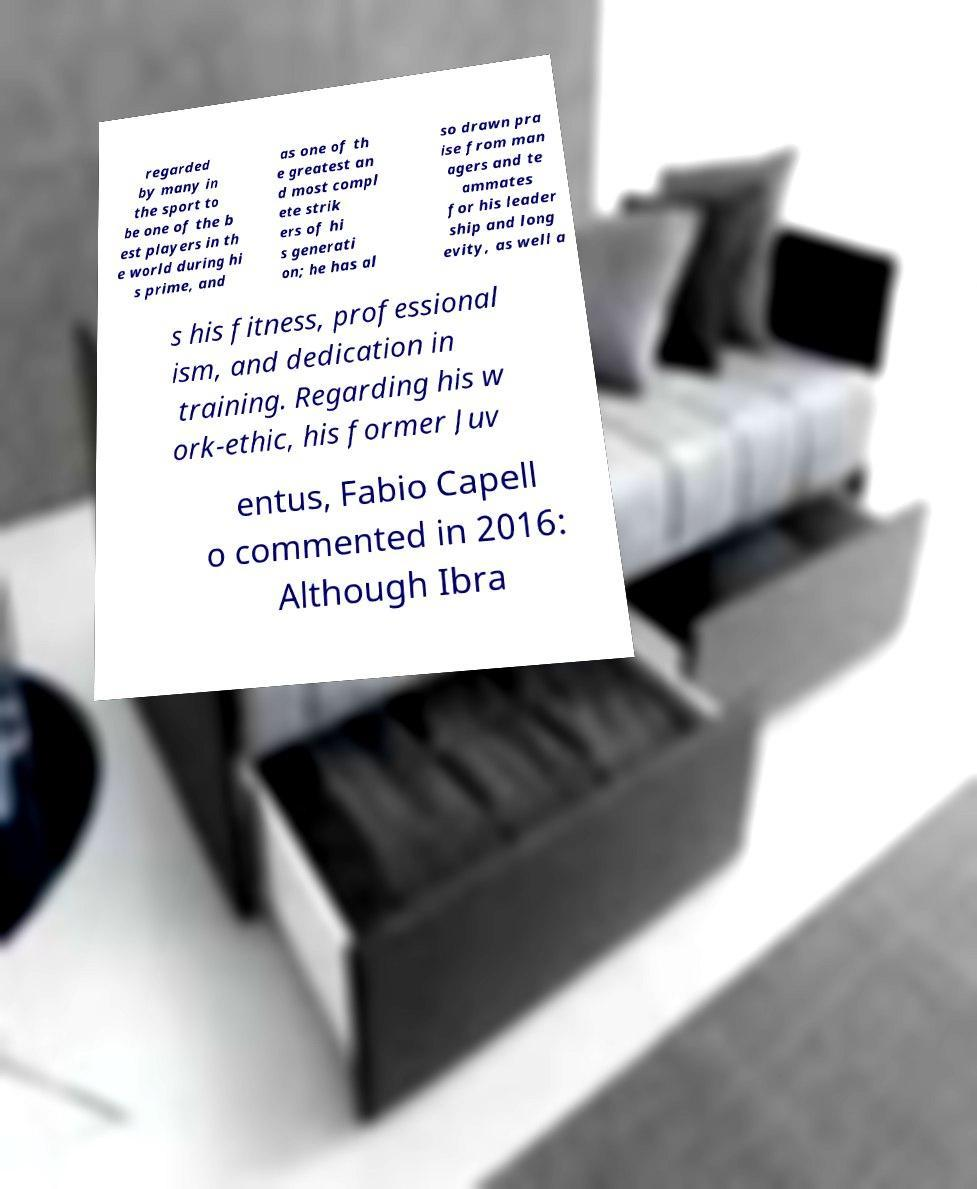There's text embedded in this image that I need extracted. Can you transcribe it verbatim? regarded by many in the sport to be one of the b est players in th e world during hi s prime, and as one of th e greatest an d most compl ete strik ers of hi s generati on; he has al so drawn pra ise from man agers and te ammates for his leader ship and long evity, as well a s his fitness, professional ism, and dedication in training. Regarding his w ork-ethic, his former Juv entus, Fabio Capell o commented in 2016: Although Ibra 